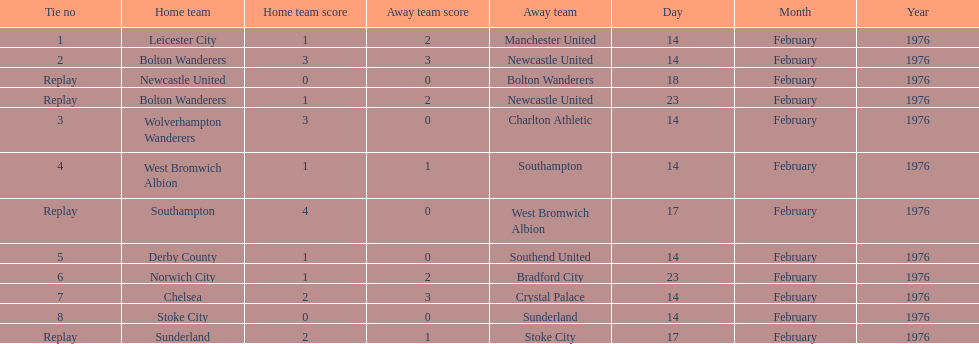How many games did the bolton wanderers and newcastle united play before there was a definitive winner in the fifth round proper? 3. 